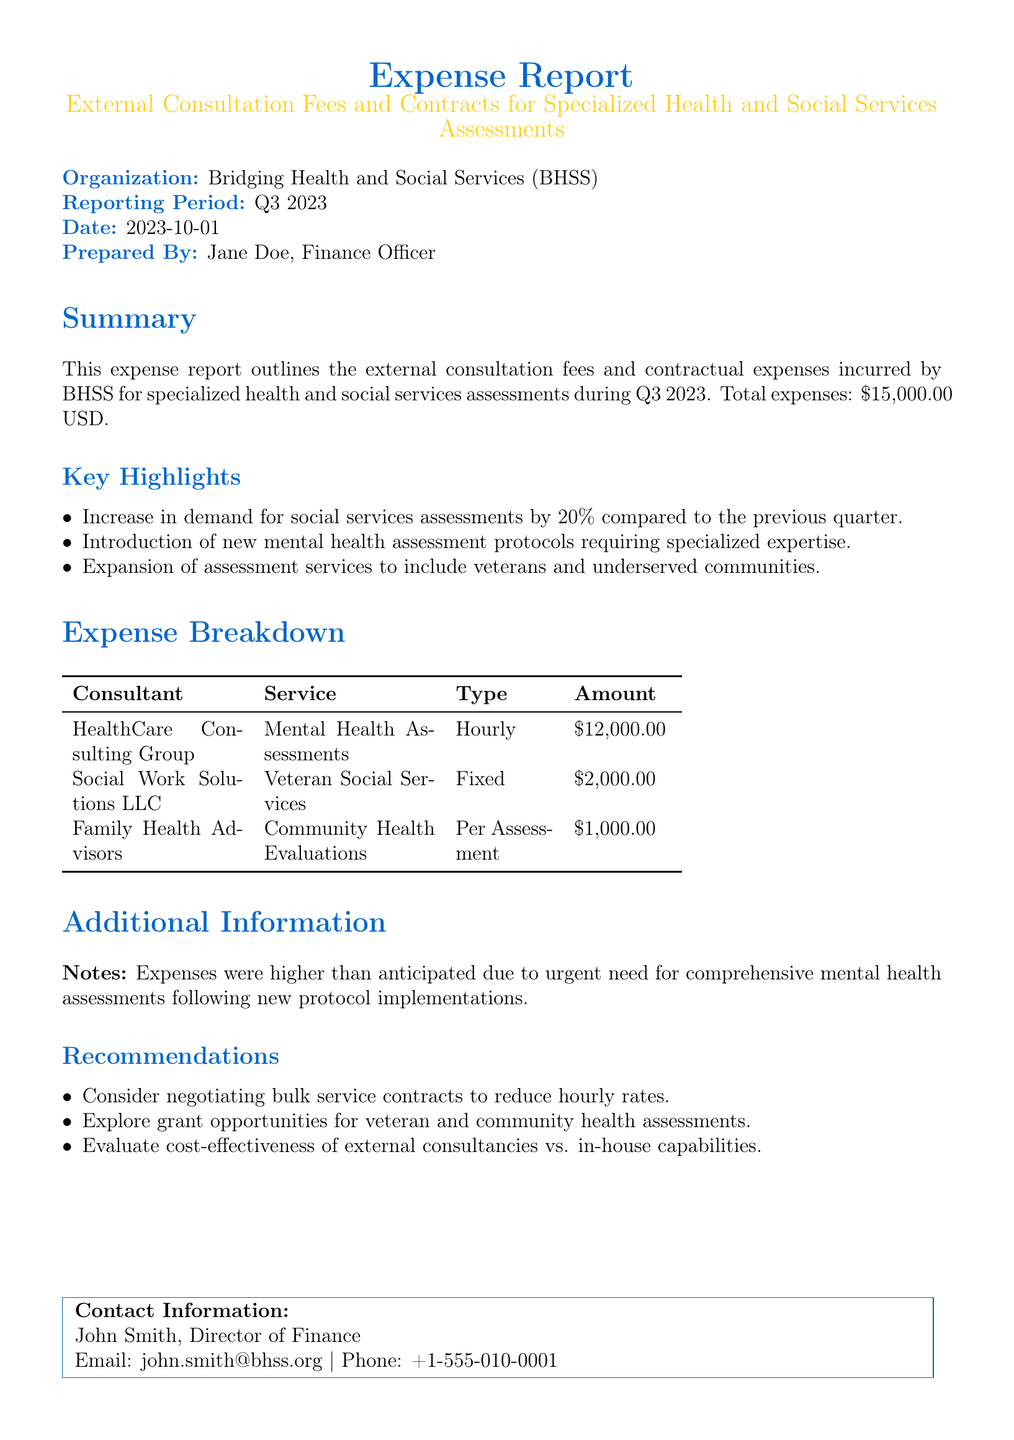What is the total expense amount? The total expense amount is stated directly in the summary of the report.
Answer: $15,000.00 USD Who prepared the report? The report includes a section for the preparer's name, which is mentioned in the document.
Answer: Jane Doe What is the reporting period for this expense report? The reporting period is specified under the header "Reporting Period."
Answer: Q3 2023 Which consultant provided mental health assessments? The consultant for mental health assessments is listed in the expense breakdown table.
Answer: HealthCare Consulting Group What type of service did Social Work Solutions LLC provide? The type of service is clearly shown in the consultant service breakdown.
Answer: Veteran Social Services How much did Family Health Advisors charge per assessment? The amount charged per assessment is indicated in the expense breakdown table.
Answer: $1,000.00 What was a key highlight in the report? Key highlights are provided in a bulleted list; one can be selected from there.
Answer: Increase in demand for social services assessments by 20% What is one recommendation provided in the report? Recommendations are listed; one can be selected as an example from that list.
Answer: Consider negotiating bulk service contracts to reduce hourly rates What was a reason for higher expenses than anticipated? The document includes a note explaining the reason for increased expenses.
Answer: Urgent need for comprehensive mental health assessments 